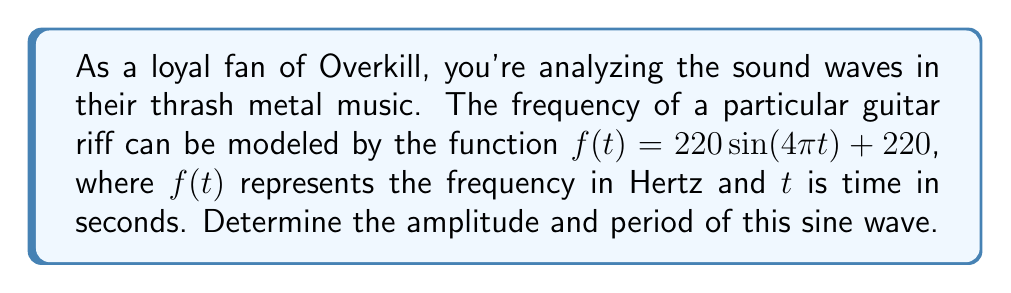Provide a solution to this math problem. To find the amplitude and period of the sine wave, we need to analyze the given function:

$f(t) = 220 \sin(4\pi t) + 220$

1. Amplitude:
The general form of a sine function is $A \sin(B(t-C)) + D$, where $A$ is the amplitude.
In our function, we have $220 \sin(4\pi t) + 220$
Comparing this to the general form, we can see that $A = 220$

2. Period:
The period of a sine function is given by the formula:

$$ \text{Period} = \frac{2\pi}{|B|} $$

In our function, $B = 4\pi$

So, we calculate:

$$ \text{Period} = \frac{2\pi}{|4\pi|} = \frac{2\pi}{4\pi} = \frac{1}{2} = 0.5 \text{ seconds} $$

This means the sound wave completes one full cycle every 0.5 seconds, which is consistent with the fast-paced nature of Overkill's thrash metal music.
Answer: Amplitude: 220 Hz
Period: 0.5 seconds 